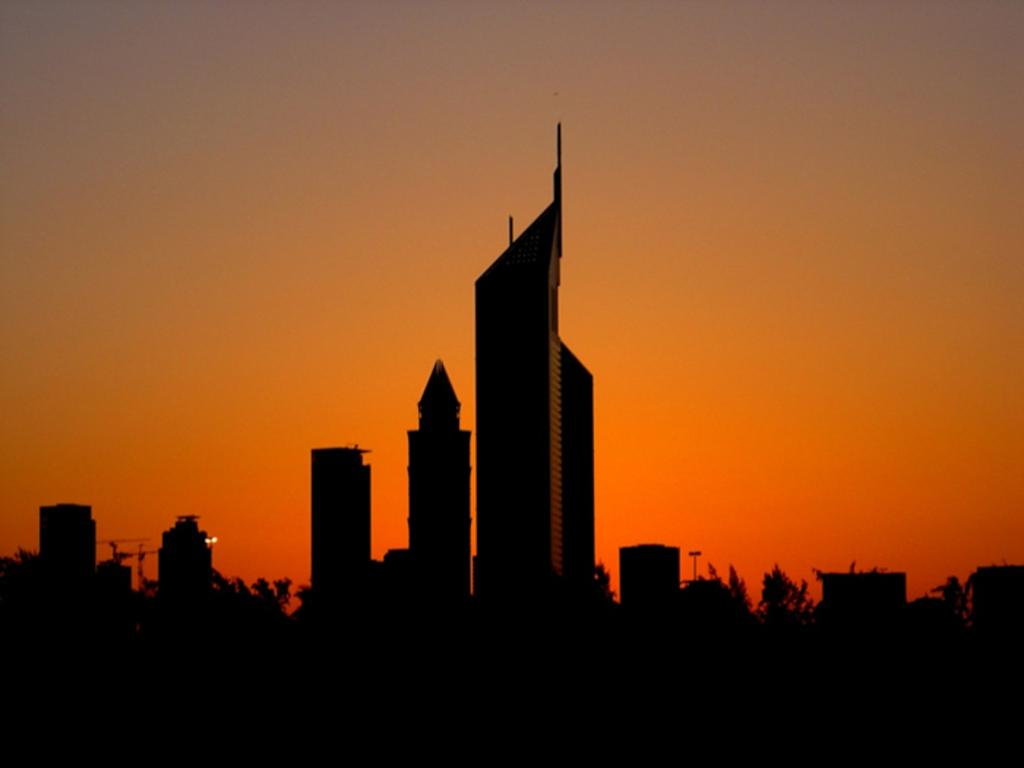What type of structures can be seen in the image? There are many buildings in the image. What other elements are present in the image besides buildings? There are trees and the sky visible in the image. What is the color of the sky in the image? The color of the sky is red. What type of music can be heard playing in the image? There is no music present in the image, as it is a still photograph. 